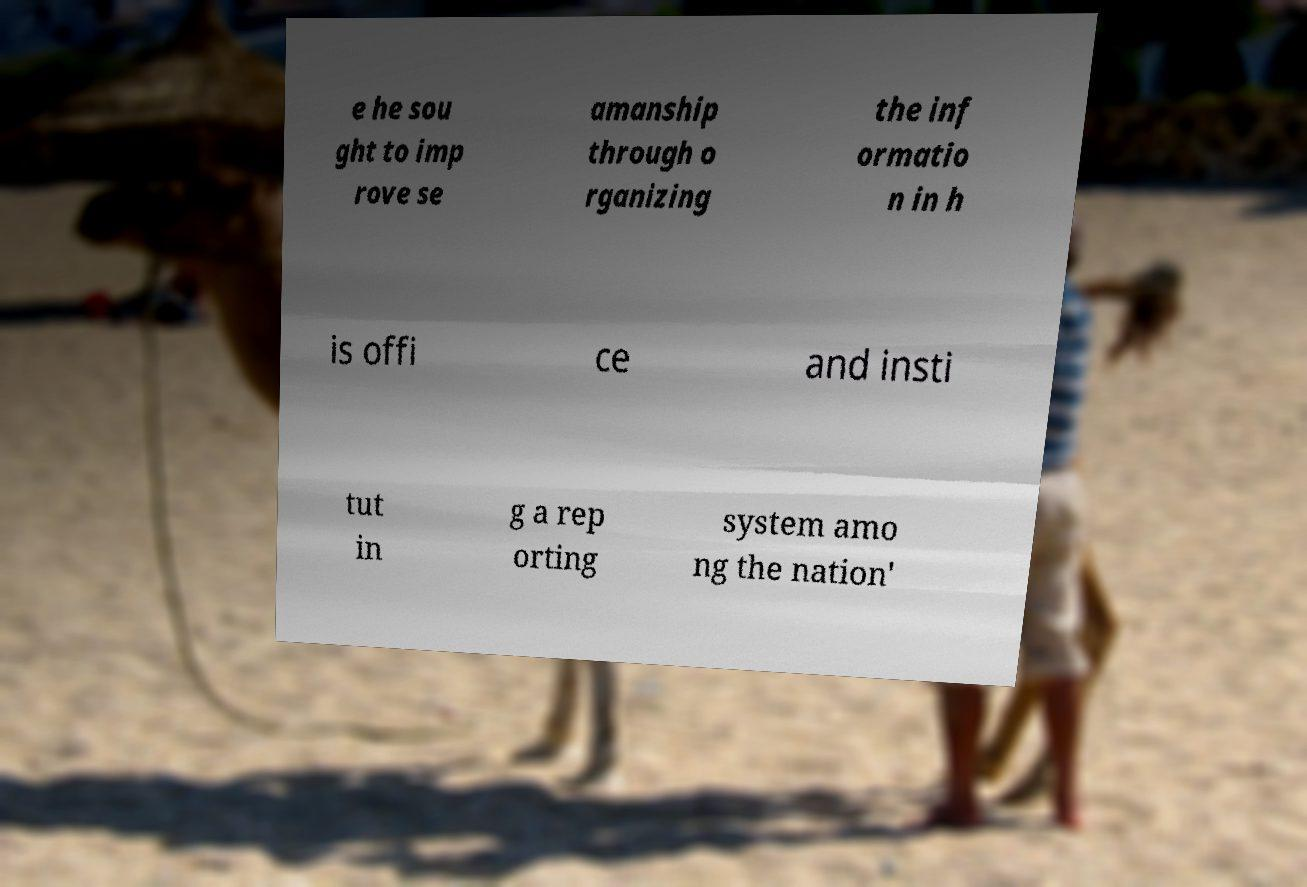Can you read and provide the text displayed in the image?This photo seems to have some interesting text. Can you extract and type it out for me? e he sou ght to imp rove se amanship through o rganizing the inf ormatio n in h is offi ce and insti tut in g a rep orting system amo ng the nation' 